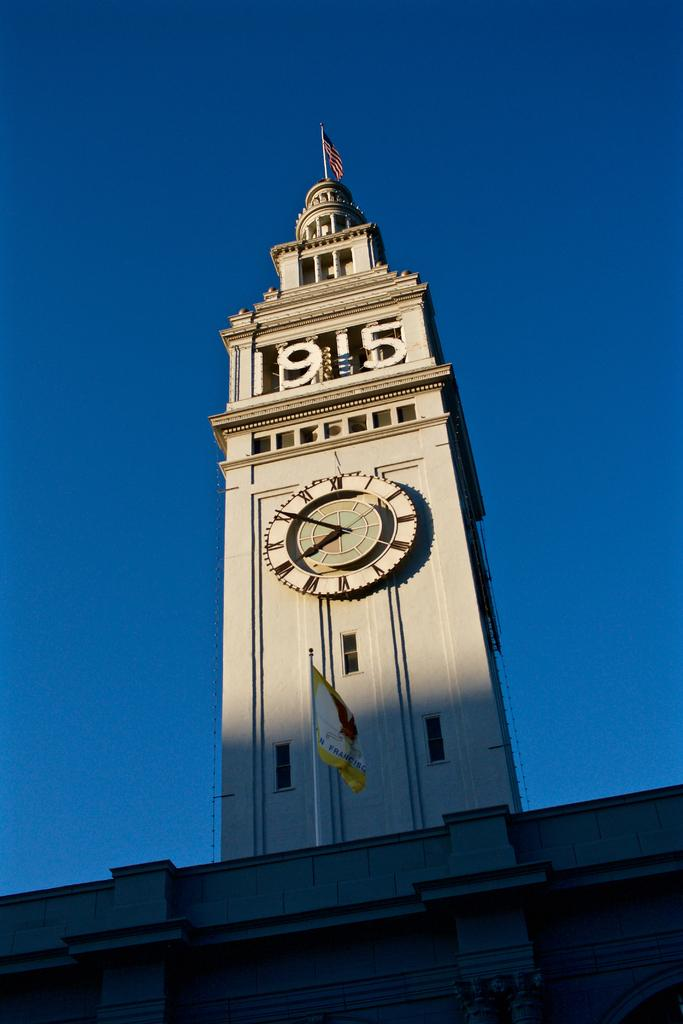What type of structure is in the image? There is a building in the image. What is a prominent feature of the building? There is a clock tower in the middle of the building. What can be seen on the clock tower? There is a clock visible on the clock tower. How many flags are present in the image? There are two flags in the image. What is visible at the top of the image? The sky is visible at the top of the image. What type of account can be seen on the marble surface in the image? There is no mention of an account or a marble surface in the image; it features a building with a clock tower and flags. 